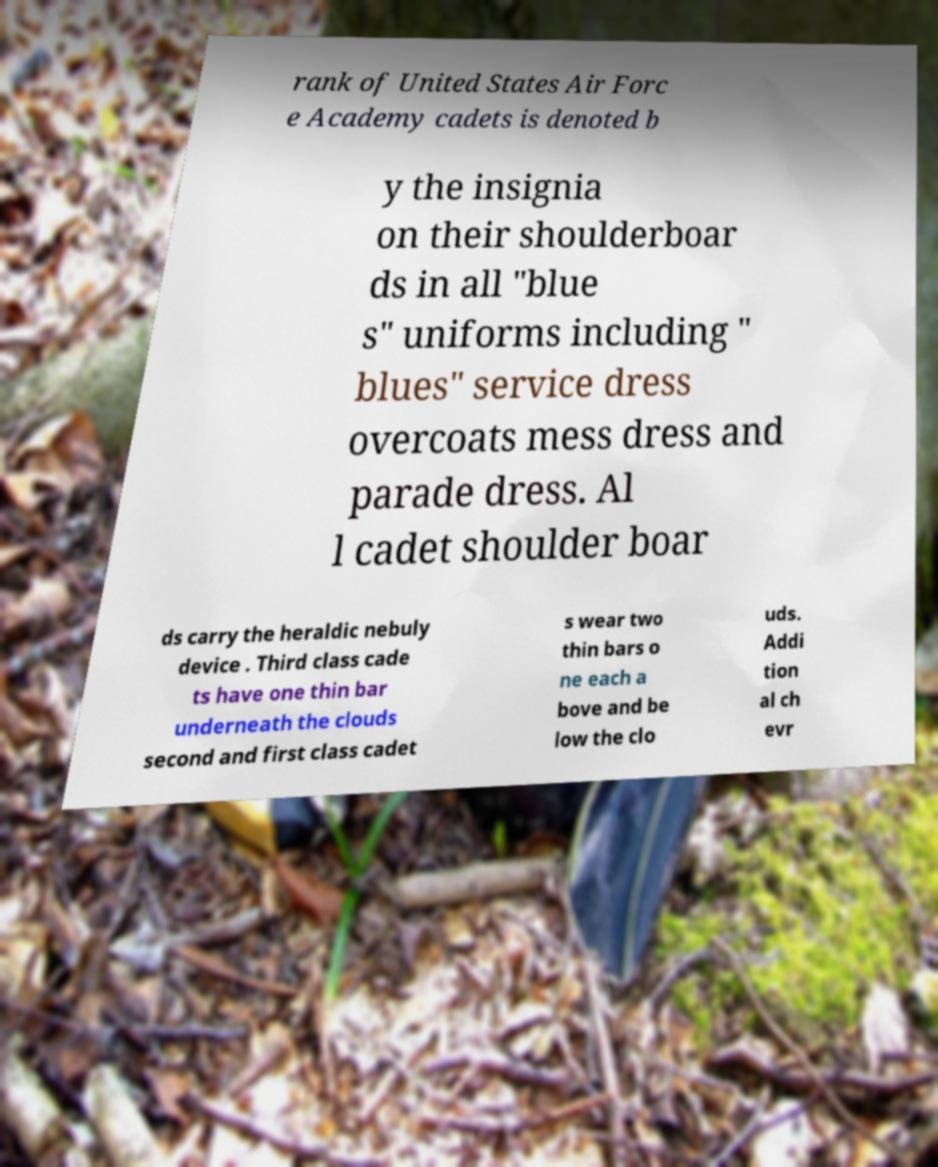Please identify and transcribe the text found in this image. rank of United States Air Forc e Academy cadets is denoted b y the insignia on their shoulderboar ds in all "blue s" uniforms including " blues" service dress overcoats mess dress and parade dress. Al l cadet shoulder boar ds carry the heraldic nebuly device . Third class cade ts have one thin bar underneath the clouds second and first class cadet s wear two thin bars o ne each a bove and be low the clo uds. Addi tion al ch evr 